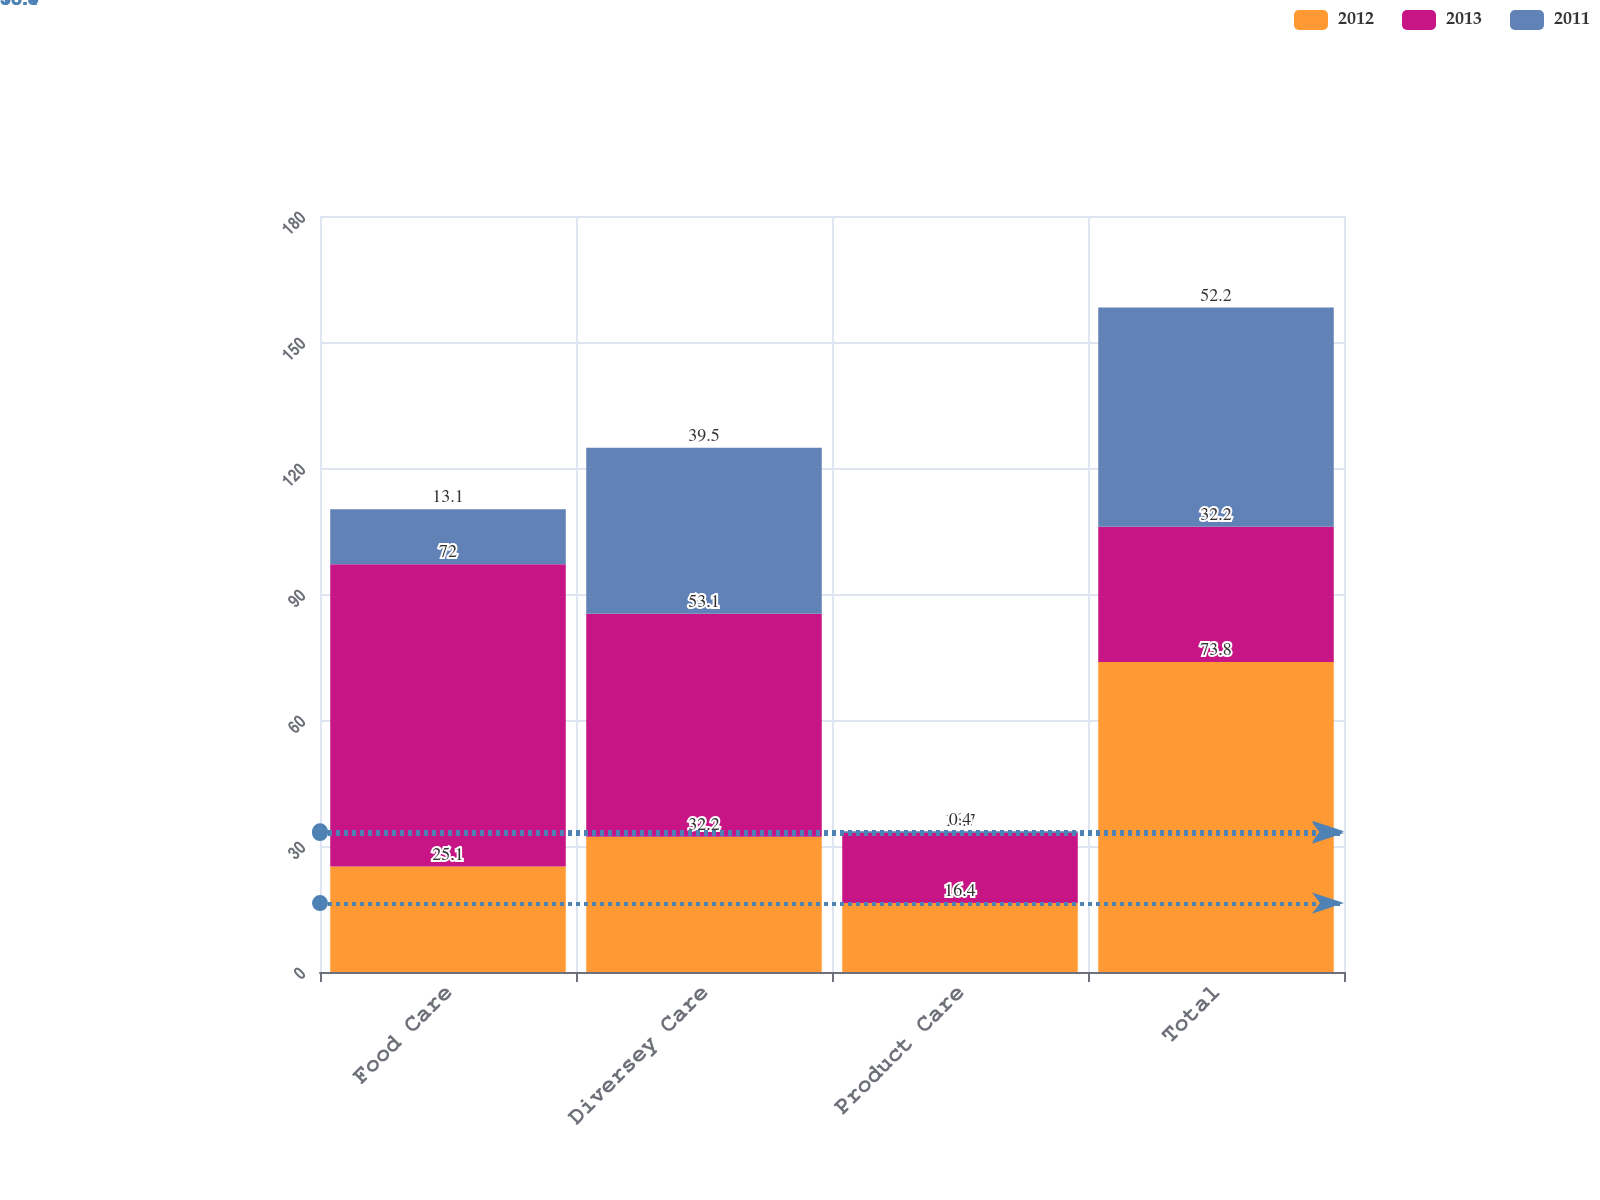<chart> <loc_0><loc_0><loc_500><loc_500><stacked_bar_chart><ecel><fcel>Food Care<fcel>Diversey Care<fcel>Product Care<fcel>Total<nl><fcel>2012<fcel>25.1<fcel>32.2<fcel>16.4<fcel>73.8<nl><fcel>2013<fcel>72<fcel>53.1<fcel>16.7<fcel>32.2<nl><fcel>2011<fcel>13.1<fcel>39.5<fcel>0.4<fcel>52.2<nl></chart> 